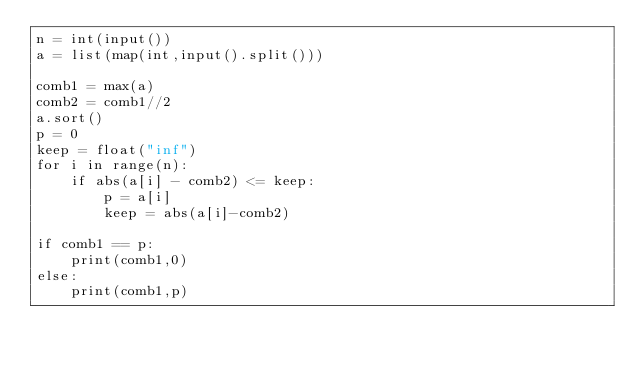<code> <loc_0><loc_0><loc_500><loc_500><_Python_>n = int(input())
a = list(map(int,input().split()))

comb1 = max(a)
comb2 = comb1//2
a.sort()
p = 0
keep = float("inf")
for i in range(n):
    if abs(a[i] - comb2) <= keep:
        p = a[i]
        keep = abs(a[i]-comb2)

if comb1 == p:
    print(comb1,0)
else:
    print(comb1,p)</code> 